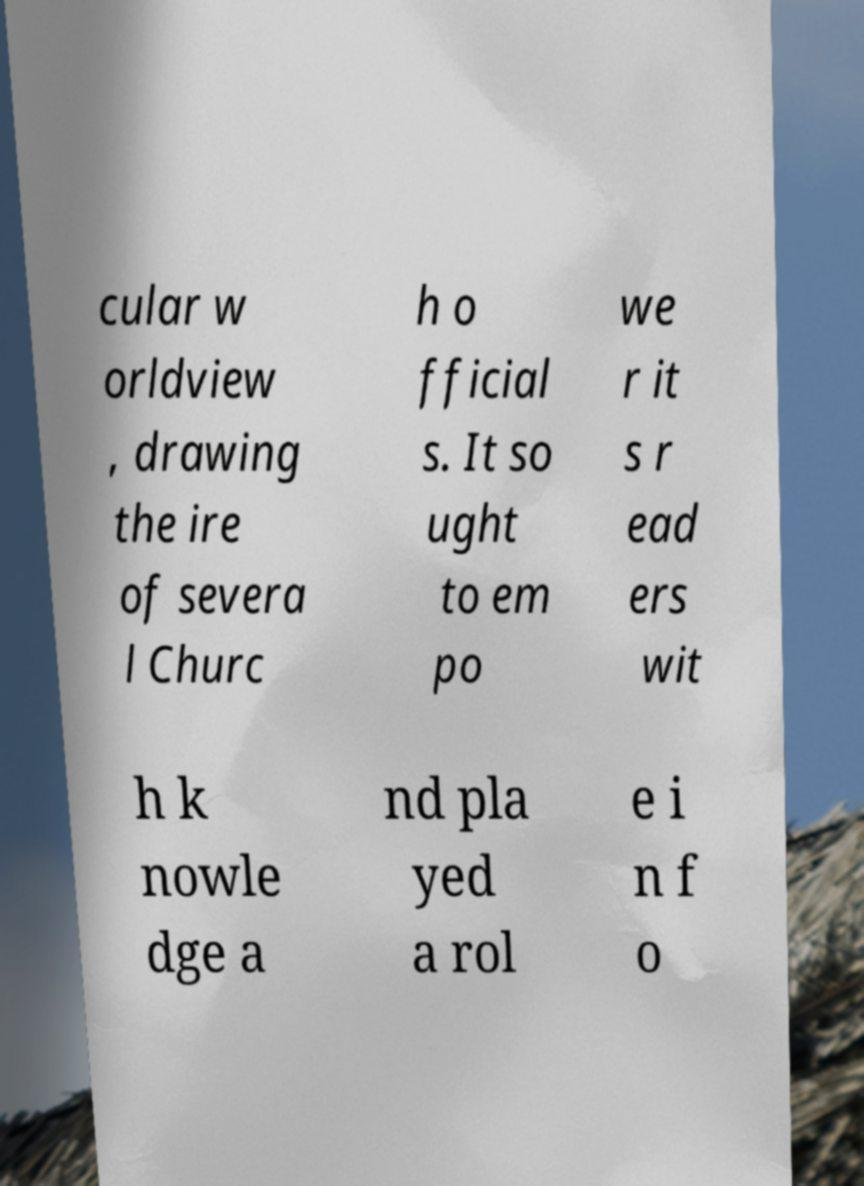Could you extract and type out the text from this image? cular w orldview , drawing the ire of severa l Churc h o fficial s. It so ught to em po we r it s r ead ers wit h k nowle dge a nd pla yed a rol e i n f o 